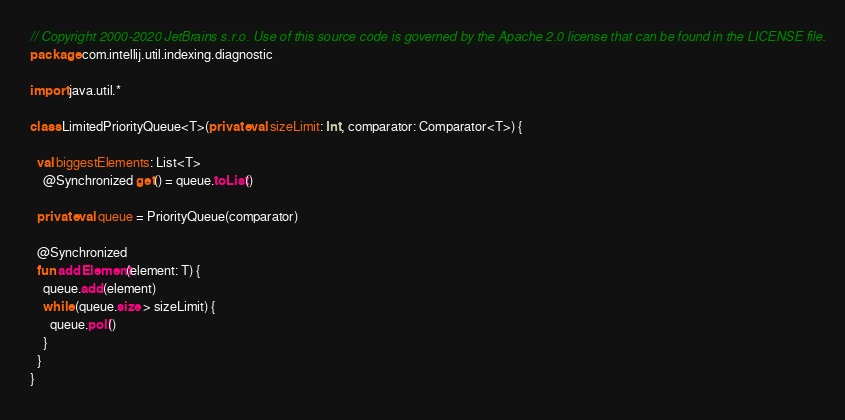<code> <loc_0><loc_0><loc_500><loc_500><_Kotlin_>// Copyright 2000-2020 JetBrains s.r.o. Use of this source code is governed by the Apache 2.0 license that can be found in the LICENSE file.
package com.intellij.util.indexing.diagnostic

import java.util.*

class LimitedPriorityQueue<T>(private val sizeLimit: Int, comparator: Comparator<T>) {

  val biggestElements: List<T>
    @Synchronized get() = queue.toList()

  private val queue = PriorityQueue(comparator)

  @Synchronized
  fun addElement(element: T) {
    queue.add(element)
    while (queue.size > sizeLimit) {
      queue.poll()
    }
  }
}</code> 